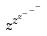<formula> <loc_0><loc_0><loc_500><loc_500>z ^ { z ^ { z ^ { - ^ { - ^ { - } } } } }</formula> 